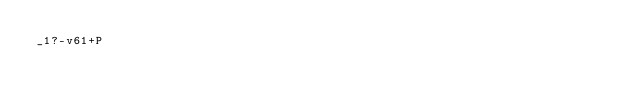<code> <loc_0><loc_0><loc_500><loc_500><_dc_>_1?-v61+P</code> 